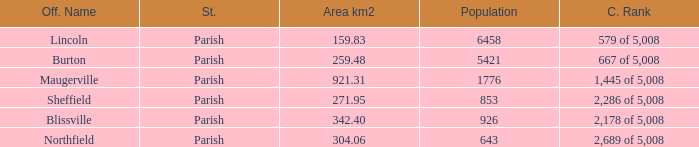What are the official name(s) of places with an area of 304.06 km2? Northfield. 